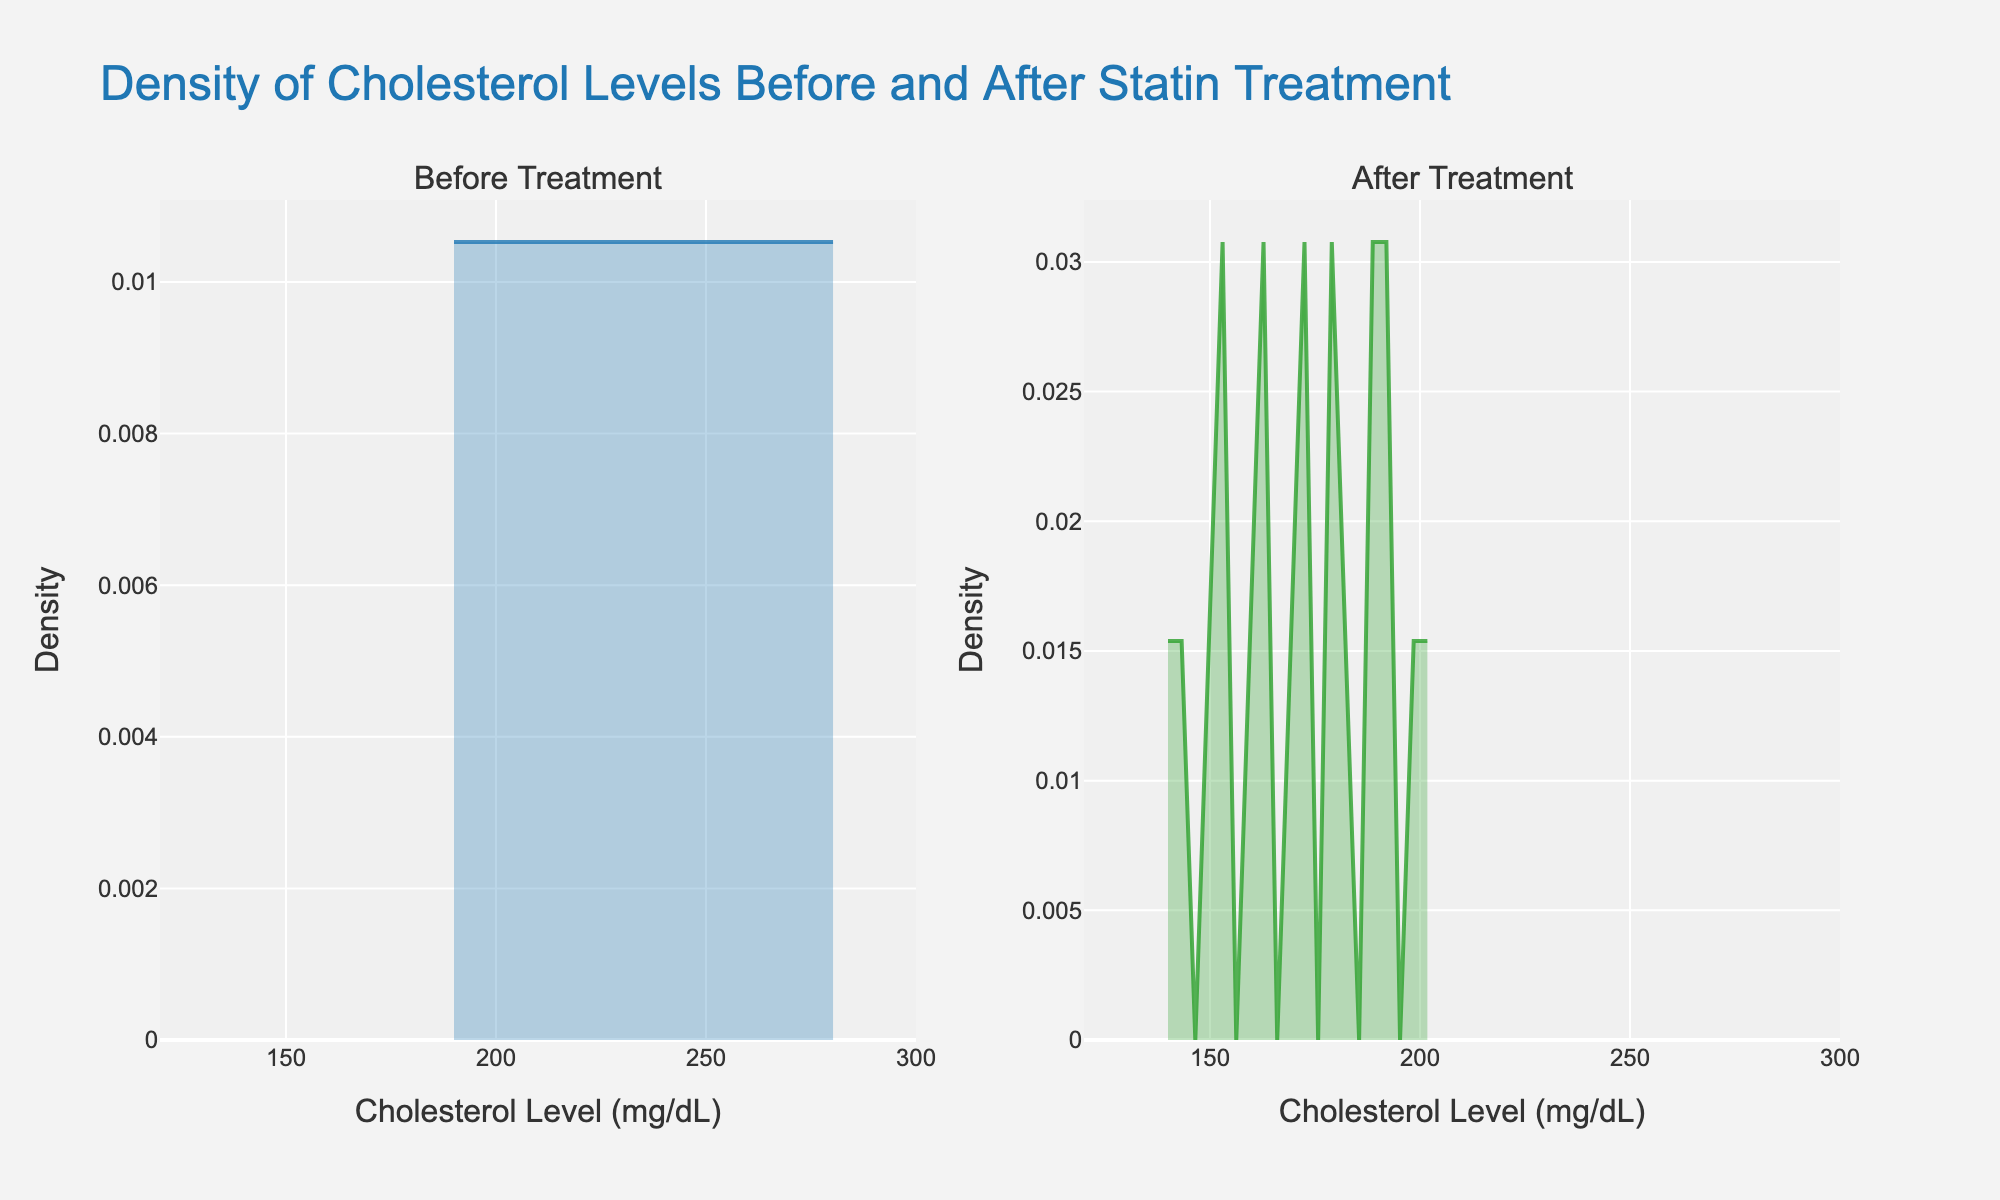What's the title of the figure? The title is displayed at the top of the figure and summarizes the main topic of the plot. In this case, it states 'Density of Cholesterol Levels Before and After Statin Treatment'.
Answer: Density of Cholesterol Levels Before and After Statin Treatment What do the x-axes in both subplots represent? The x-axes in both subplots are labeled 'Cholesterol Level (mg/dL)', indicating that they represent cholesterol levels measured in milligrams per deciliter.
Answer: Cholesterol Level (mg/dL) What do the y-axes in both subplots represent? The y-axes in both subplots are labeled 'Density', indicating that they represent the density of patients' cholesterol levels.
Answer: Density What color represents the density plot for cholesterol levels before treatment? The color representing the density plot for cholesterol levels before treatment is a shade of blue, as seen in the 'Before Treatment' subplot.
Answer: Blue What color represents the density plot for cholesterol levels after treatment? The color representing the density plot for cholesterol levels after treatment is a shade of green, as seen in the 'After Treatment' subplot.
Answer: Green Which subplot has a higher peak density value? By observing the height of the peak in the density plots, the 'After Treatment' subplot has a higher peak density value compared to the 'Before Treatment' subplot.
Answer: After Treatment What is the range of cholesterol levels represented on the x-axis? The x-axis range for both subplots spans from 120 to 300 mg/dL, as indicated by the axis labels.
Answer: 120 to 300 mg/dL How do the peak densities compare between the 'Before Treatment' and 'After Treatment' subplots? The peak density in the 'After Treatment' subplot is higher than that in the 'Before Treatment' subplot, indicating a higher concentration of patients with similar cholesterol levels after treatment.
Answer: Higher in 'After Treatment' What general trend can be inferred about cholesterol levels after statin treatment? The peak in the 'After Treatment' subplot is higher and located at a lower cholesterol level range compared to 'Before Treatment', indicating that the statin treatment lowered the cholesterol levels for most patients.
Answer: Cholesterol levels decreased What is the approximate cholesterol level value where the peak density occurs in the 'After Treatment' subplot? Observing the 'After Treatment' subplot, the peak density occurs at around 175 mg/dL, indicating the most common cholesterol level after treatment.
Answer: ~175 mg/dL 